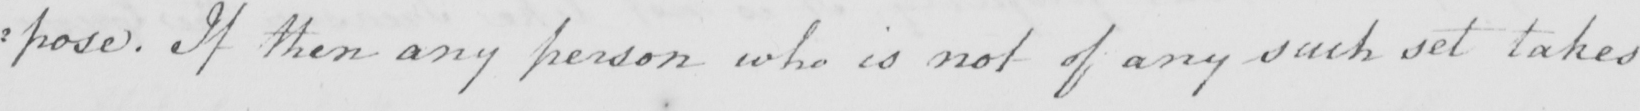What text is written in this handwritten line? : pose . If then any person who is not of any such set takes 